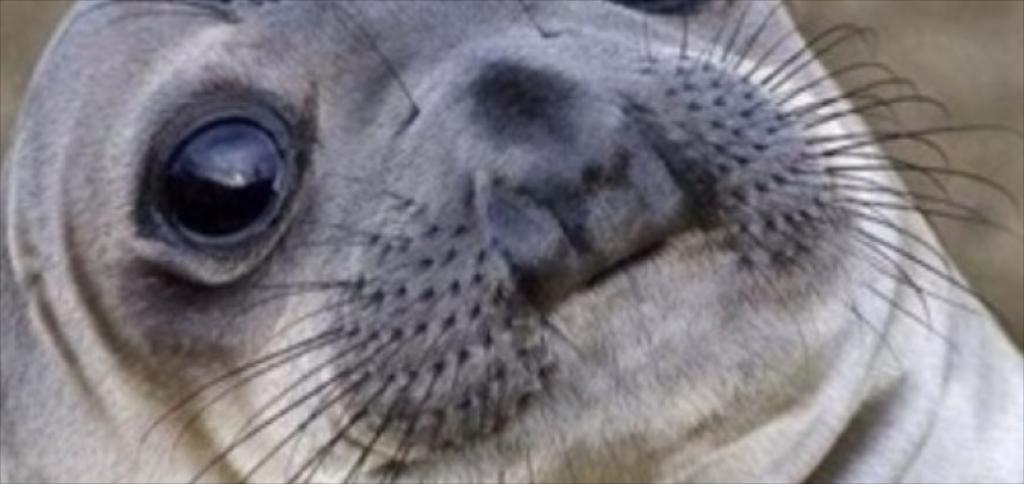What type of animal is in the image? There is a seal in the image. What type of wrench is the seal using in the image? There is no wrench present in the image; it features a seal. What type of soda is the seal drinking from in the image? There is no soda present in the image; it features a seal. 